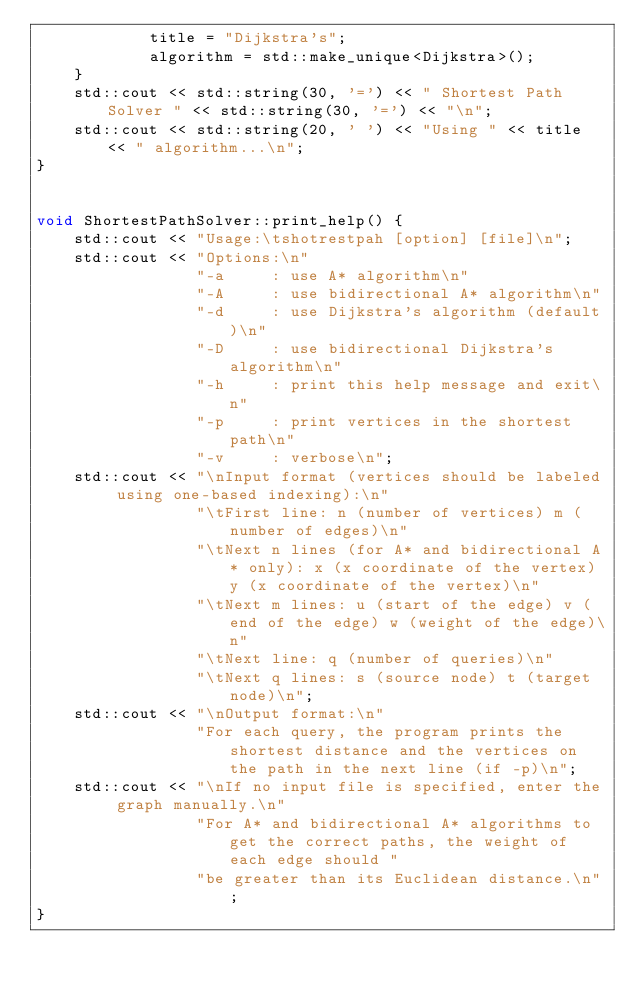<code> <loc_0><loc_0><loc_500><loc_500><_C++_>            title = "Dijkstra's";
            algorithm = std::make_unique<Dijkstra>();
    }
    std::cout << std::string(30, '=') << " Shortest Path Solver " << std::string(30, '=') << "\n";
    std::cout << std::string(20, ' ') << "Using " << title << " algorithm...\n";
}


void ShortestPathSolver::print_help() {
    std::cout << "Usage:\tshotrestpah [option] [file]\n";
    std::cout << "Options:\n"
                 "-a     : use A* algorithm\n"
                 "-A     : use bidirectional A* algorithm\n"
                 "-d     : use Dijkstra's algorithm (default)\n"
                 "-D     : use bidirectional Dijkstra's algorithm\n"
                 "-h     : print this help message and exit\n"
                 "-p     : print vertices in the shortest path\n"
                 "-v     : verbose\n";
    std::cout << "\nInput format (vertices should be labeled using one-based indexing):\n"
                 "\tFirst line: n (number of vertices) m (number of edges)\n"
                 "\tNext n lines (for A* and bidirectional A* only): x (x coordinate of the vertex) y (x coordinate of the vertex)\n"
                 "\tNext m lines: u (start of the edge) v (end of the edge) w (weight of the edge)\n"
                 "\tNext line: q (number of queries)\n"
                 "\tNext q lines: s (source node) t (target node)\n";
    std::cout << "\nOutput format:\n"
                 "For each query, the program prints the shortest distance and the vertices on the path in the next line (if -p)\n";
    std::cout << "\nIf no input file is specified, enter the graph manually.\n"
                 "For A* and bidirectional A* algorithms to get the correct paths, the weight of each edge should "
                 "be greater than its Euclidean distance.\n";
}

</code> 